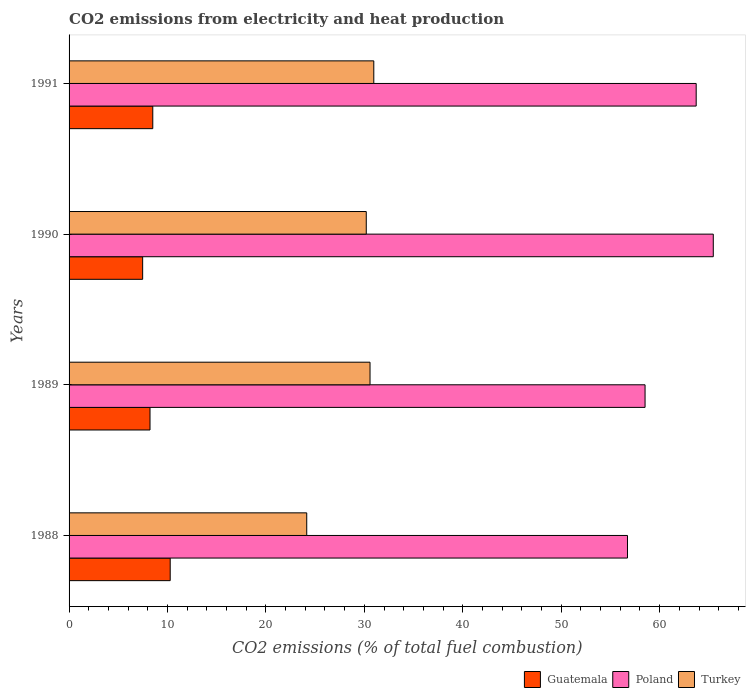How many different coloured bars are there?
Your answer should be very brief. 3. Are the number of bars per tick equal to the number of legend labels?
Keep it short and to the point. Yes. How many bars are there on the 2nd tick from the top?
Your answer should be very brief. 3. In how many cases, is the number of bars for a given year not equal to the number of legend labels?
Offer a terse response. 0. What is the amount of CO2 emitted in Guatemala in 1991?
Make the answer very short. 8.5. Across all years, what is the maximum amount of CO2 emitted in Turkey?
Keep it short and to the point. 30.96. Across all years, what is the minimum amount of CO2 emitted in Poland?
Keep it short and to the point. 56.73. In which year was the amount of CO2 emitted in Guatemala maximum?
Offer a terse response. 1988. What is the total amount of CO2 emitted in Poland in the graph?
Give a very brief answer. 244.42. What is the difference between the amount of CO2 emitted in Poland in 1990 and that in 1991?
Ensure brevity in your answer.  1.74. What is the difference between the amount of CO2 emitted in Poland in 1988 and the amount of CO2 emitted in Guatemala in 1989?
Give a very brief answer. 48.51. What is the average amount of CO2 emitted in Guatemala per year?
Keep it short and to the point. 8.62. In the year 1988, what is the difference between the amount of CO2 emitted in Poland and amount of CO2 emitted in Guatemala?
Your answer should be compact. 46.46. What is the ratio of the amount of CO2 emitted in Guatemala in 1989 to that in 1991?
Make the answer very short. 0.97. Is the amount of CO2 emitted in Guatemala in 1989 less than that in 1990?
Your response must be concise. No. Is the difference between the amount of CO2 emitted in Poland in 1990 and 1991 greater than the difference between the amount of CO2 emitted in Guatemala in 1990 and 1991?
Offer a terse response. Yes. What is the difference between the highest and the second highest amount of CO2 emitted in Poland?
Provide a short and direct response. 1.74. What is the difference between the highest and the lowest amount of CO2 emitted in Poland?
Offer a terse response. 8.72. In how many years, is the amount of CO2 emitted in Turkey greater than the average amount of CO2 emitted in Turkey taken over all years?
Make the answer very short. 3. What does the 3rd bar from the top in 1991 represents?
Offer a very short reply. Guatemala. Is it the case that in every year, the sum of the amount of CO2 emitted in Guatemala and amount of CO2 emitted in Poland is greater than the amount of CO2 emitted in Turkey?
Provide a short and direct response. Yes. Are all the bars in the graph horizontal?
Provide a succinct answer. Yes. Does the graph contain grids?
Your answer should be very brief. No. How many legend labels are there?
Give a very brief answer. 3. How are the legend labels stacked?
Provide a short and direct response. Horizontal. What is the title of the graph?
Give a very brief answer. CO2 emissions from electricity and heat production. Does "Serbia" appear as one of the legend labels in the graph?
Keep it short and to the point. No. What is the label or title of the X-axis?
Your answer should be very brief. CO2 emissions (% of total fuel combustion). What is the CO2 emissions (% of total fuel combustion) of Guatemala in 1988?
Make the answer very short. 10.27. What is the CO2 emissions (% of total fuel combustion) of Poland in 1988?
Keep it short and to the point. 56.73. What is the CO2 emissions (% of total fuel combustion) in Turkey in 1988?
Provide a short and direct response. 24.15. What is the CO2 emissions (% of total fuel combustion) in Guatemala in 1989?
Offer a terse response. 8.22. What is the CO2 emissions (% of total fuel combustion) in Poland in 1989?
Your answer should be very brief. 58.52. What is the CO2 emissions (% of total fuel combustion) in Turkey in 1989?
Your response must be concise. 30.58. What is the CO2 emissions (% of total fuel combustion) in Guatemala in 1990?
Offer a terse response. 7.48. What is the CO2 emissions (% of total fuel combustion) in Poland in 1990?
Ensure brevity in your answer.  65.45. What is the CO2 emissions (% of total fuel combustion) of Turkey in 1990?
Provide a succinct answer. 30.19. What is the CO2 emissions (% of total fuel combustion) in Guatemala in 1991?
Offer a terse response. 8.5. What is the CO2 emissions (% of total fuel combustion) of Poland in 1991?
Ensure brevity in your answer.  63.71. What is the CO2 emissions (% of total fuel combustion) in Turkey in 1991?
Your answer should be very brief. 30.96. Across all years, what is the maximum CO2 emissions (% of total fuel combustion) of Guatemala?
Your response must be concise. 10.27. Across all years, what is the maximum CO2 emissions (% of total fuel combustion) in Poland?
Your response must be concise. 65.45. Across all years, what is the maximum CO2 emissions (% of total fuel combustion) of Turkey?
Keep it short and to the point. 30.96. Across all years, what is the minimum CO2 emissions (% of total fuel combustion) of Guatemala?
Give a very brief answer. 7.48. Across all years, what is the minimum CO2 emissions (% of total fuel combustion) of Poland?
Offer a terse response. 56.73. Across all years, what is the minimum CO2 emissions (% of total fuel combustion) of Turkey?
Your answer should be very brief. 24.15. What is the total CO2 emissions (% of total fuel combustion) of Guatemala in the graph?
Your answer should be compact. 34.48. What is the total CO2 emissions (% of total fuel combustion) of Poland in the graph?
Provide a succinct answer. 244.42. What is the total CO2 emissions (% of total fuel combustion) in Turkey in the graph?
Give a very brief answer. 115.88. What is the difference between the CO2 emissions (% of total fuel combustion) in Guatemala in 1988 and that in 1989?
Your response must be concise. 2.05. What is the difference between the CO2 emissions (% of total fuel combustion) of Poland in 1988 and that in 1989?
Offer a terse response. -1.79. What is the difference between the CO2 emissions (% of total fuel combustion) of Turkey in 1988 and that in 1989?
Keep it short and to the point. -6.43. What is the difference between the CO2 emissions (% of total fuel combustion) of Guatemala in 1988 and that in 1990?
Ensure brevity in your answer.  2.8. What is the difference between the CO2 emissions (% of total fuel combustion) of Poland in 1988 and that in 1990?
Ensure brevity in your answer.  -8.72. What is the difference between the CO2 emissions (% of total fuel combustion) of Turkey in 1988 and that in 1990?
Your answer should be compact. -6.05. What is the difference between the CO2 emissions (% of total fuel combustion) in Guatemala in 1988 and that in 1991?
Offer a very short reply. 1.77. What is the difference between the CO2 emissions (% of total fuel combustion) of Poland in 1988 and that in 1991?
Keep it short and to the point. -6.98. What is the difference between the CO2 emissions (% of total fuel combustion) of Turkey in 1988 and that in 1991?
Provide a succinct answer. -6.81. What is the difference between the CO2 emissions (% of total fuel combustion) in Guatemala in 1989 and that in 1990?
Make the answer very short. 0.75. What is the difference between the CO2 emissions (% of total fuel combustion) in Poland in 1989 and that in 1990?
Your answer should be very brief. -6.93. What is the difference between the CO2 emissions (% of total fuel combustion) in Turkey in 1989 and that in 1990?
Offer a very short reply. 0.38. What is the difference between the CO2 emissions (% of total fuel combustion) of Guatemala in 1989 and that in 1991?
Give a very brief answer. -0.28. What is the difference between the CO2 emissions (% of total fuel combustion) of Poland in 1989 and that in 1991?
Give a very brief answer. -5.19. What is the difference between the CO2 emissions (% of total fuel combustion) of Turkey in 1989 and that in 1991?
Give a very brief answer. -0.38. What is the difference between the CO2 emissions (% of total fuel combustion) in Guatemala in 1990 and that in 1991?
Give a very brief answer. -1.03. What is the difference between the CO2 emissions (% of total fuel combustion) in Poland in 1990 and that in 1991?
Offer a very short reply. 1.74. What is the difference between the CO2 emissions (% of total fuel combustion) of Turkey in 1990 and that in 1991?
Your answer should be very brief. -0.76. What is the difference between the CO2 emissions (% of total fuel combustion) in Guatemala in 1988 and the CO2 emissions (% of total fuel combustion) in Poland in 1989?
Give a very brief answer. -48.25. What is the difference between the CO2 emissions (% of total fuel combustion) in Guatemala in 1988 and the CO2 emissions (% of total fuel combustion) in Turkey in 1989?
Give a very brief answer. -20.3. What is the difference between the CO2 emissions (% of total fuel combustion) of Poland in 1988 and the CO2 emissions (% of total fuel combustion) of Turkey in 1989?
Offer a terse response. 26.16. What is the difference between the CO2 emissions (% of total fuel combustion) of Guatemala in 1988 and the CO2 emissions (% of total fuel combustion) of Poland in 1990?
Keep it short and to the point. -55.18. What is the difference between the CO2 emissions (% of total fuel combustion) in Guatemala in 1988 and the CO2 emissions (% of total fuel combustion) in Turkey in 1990?
Keep it short and to the point. -19.92. What is the difference between the CO2 emissions (% of total fuel combustion) of Poland in 1988 and the CO2 emissions (% of total fuel combustion) of Turkey in 1990?
Offer a very short reply. 26.54. What is the difference between the CO2 emissions (% of total fuel combustion) of Guatemala in 1988 and the CO2 emissions (% of total fuel combustion) of Poland in 1991?
Give a very brief answer. -53.44. What is the difference between the CO2 emissions (% of total fuel combustion) in Guatemala in 1988 and the CO2 emissions (% of total fuel combustion) in Turkey in 1991?
Give a very brief answer. -20.69. What is the difference between the CO2 emissions (% of total fuel combustion) of Poland in 1988 and the CO2 emissions (% of total fuel combustion) of Turkey in 1991?
Your response must be concise. 25.77. What is the difference between the CO2 emissions (% of total fuel combustion) in Guatemala in 1989 and the CO2 emissions (% of total fuel combustion) in Poland in 1990?
Keep it short and to the point. -57.23. What is the difference between the CO2 emissions (% of total fuel combustion) of Guatemala in 1989 and the CO2 emissions (% of total fuel combustion) of Turkey in 1990?
Provide a short and direct response. -21.97. What is the difference between the CO2 emissions (% of total fuel combustion) of Poland in 1989 and the CO2 emissions (% of total fuel combustion) of Turkey in 1990?
Provide a succinct answer. 28.32. What is the difference between the CO2 emissions (% of total fuel combustion) of Guatemala in 1989 and the CO2 emissions (% of total fuel combustion) of Poland in 1991?
Keep it short and to the point. -55.49. What is the difference between the CO2 emissions (% of total fuel combustion) of Guatemala in 1989 and the CO2 emissions (% of total fuel combustion) of Turkey in 1991?
Provide a short and direct response. -22.74. What is the difference between the CO2 emissions (% of total fuel combustion) of Poland in 1989 and the CO2 emissions (% of total fuel combustion) of Turkey in 1991?
Offer a very short reply. 27.56. What is the difference between the CO2 emissions (% of total fuel combustion) in Guatemala in 1990 and the CO2 emissions (% of total fuel combustion) in Poland in 1991?
Your answer should be compact. -56.24. What is the difference between the CO2 emissions (% of total fuel combustion) of Guatemala in 1990 and the CO2 emissions (% of total fuel combustion) of Turkey in 1991?
Your response must be concise. -23.48. What is the difference between the CO2 emissions (% of total fuel combustion) in Poland in 1990 and the CO2 emissions (% of total fuel combustion) in Turkey in 1991?
Provide a short and direct response. 34.49. What is the average CO2 emissions (% of total fuel combustion) of Guatemala per year?
Offer a terse response. 8.62. What is the average CO2 emissions (% of total fuel combustion) in Poland per year?
Offer a very short reply. 61.1. What is the average CO2 emissions (% of total fuel combustion) of Turkey per year?
Your answer should be compact. 28.97. In the year 1988, what is the difference between the CO2 emissions (% of total fuel combustion) of Guatemala and CO2 emissions (% of total fuel combustion) of Poland?
Keep it short and to the point. -46.46. In the year 1988, what is the difference between the CO2 emissions (% of total fuel combustion) in Guatemala and CO2 emissions (% of total fuel combustion) in Turkey?
Offer a very short reply. -13.87. In the year 1988, what is the difference between the CO2 emissions (% of total fuel combustion) of Poland and CO2 emissions (% of total fuel combustion) of Turkey?
Give a very brief answer. 32.59. In the year 1989, what is the difference between the CO2 emissions (% of total fuel combustion) of Guatemala and CO2 emissions (% of total fuel combustion) of Poland?
Offer a terse response. -50.3. In the year 1989, what is the difference between the CO2 emissions (% of total fuel combustion) in Guatemala and CO2 emissions (% of total fuel combustion) in Turkey?
Ensure brevity in your answer.  -22.35. In the year 1989, what is the difference between the CO2 emissions (% of total fuel combustion) of Poland and CO2 emissions (% of total fuel combustion) of Turkey?
Provide a short and direct response. 27.94. In the year 1990, what is the difference between the CO2 emissions (% of total fuel combustion) in Guatemala and CO2 emissions (% of total fuel combustion) in Poland?
Provide a short and direct response. -57.97. In the year 1990, what is the difference between the CO2 emissions (% of total fuel combustion) of Guatemala and CO2 emissions (% of total fuel combustion) of Turkey?
Your answer should be compact. -22.72. In the year 1990, what is the difference between the CO2 emissions (% of total fuel combustion) of Poland and CO2 emissions (% of total fuel combustion) of Turkey?
Provide a succinct answer. 35.26. In the year 1991, what is the difference between the CO2 emissions (% of total fuel combustion) of Guatemala and CO2 emissions (% of total fuel combustion) of Poland?
Provide a succinct answer. -55.21. In the year 1991, what is the difference between the CO2 emissions (% of total fuel combustion) in Guatemala and CO2 emissions (% of total fuel combustion) in Turkey?
Offer a very short reply. -22.46. In the year 1991, what is the difference between the CO2 emissions (% of total fuel combustion) of Poland and CO2 emissions (% of total fuel combustion) of Turkey?
Your response must be concise. 32.75. What is the ratio of the CO2 emissions (% of total fuel combustion) in Guatemala in 1988 to that in 1989?
Provide a succinct answer. 1.25. What is the ratio of the CO2 emissions (% of total fuel combustion) of Poland in 1988 to that in 1989?
Ensure brevity in your answer.  0.97. What is the ratio of the CO2 emissions (% of total fuel combustion) in Turkey in 1988 to that in 1989?
Your answer should be compact. 0.79. What is the ratio of the CO2 emissions (% of total fuel combustion) in Guatemala in 1988 to that in 1990?
Your response must be concise. 1.37. What is the ratio of the CO2 emissions (% of total fuel combustion) in Poland in 1988 to that in 1990?
Keep it short and to the point. 0.87. What is the ratio of the CO2 emissions (% of total fuel combustion) in Turkey in 1988 to that in 1990?
Provide a short and direct response. 0.8. What is the ratio of the CO2 emissions (% of total fuel combustion) of Guatemala in 1988 to that in 1991?
Your answer should be very brief. 1.21. What is the ratio of the CO2 emissions (% of total fuel combustion) of Poland in 1988 to that in 1991?
Your answer should be very brief. 0.89. What is the ratio of the CO2 emissions (% of total fuel combustion) in Turkey in 1988 to that in 1991?
Keep it short and to the point. 0.78. What is the ratio of the CO2 emissions (% of total fuel combustion) of Guatemala in 1989 to that in 1990?
Your answer should be compact. 1.1. What is the ratio of the CO2 emissions (% of total fuel combustion) of Poland in 1989 to that in 1990?
Ensure brevity in your answer.  0.89. What is the ratio of the CO2 emissions (% of total fuel combustion) of Turkey in 1989 to that in 1990?
Make the answer very short. 1.01. What is the ratio of the CO2 emissions (% of total fuel combustion) in Guatemala in 1989 to that in 1991?
Offer a terse response. 0.97. What is the ratio of the CO2 emissions (% of total fuel combustion) in Poland in 1989 to that in 1991?
Provide a succinct answer. 0.92. What is the ratio of the CO2 emissions (% of total fuel combustion) in Turkey in 1989 to that in 1991?
Your answer should be compact. 0.99. What is the ratio of the CO2 emissions (% of total fuel combustion) in Guatemala in 1990 to that in 1991?
Offer a very short reply. 0.88. What is the ratio of the CO2 emissions (% of total fuel combustion) in Poland in 1990 to that in 1991?
Offer a very short reply. 1.03. What is the ratio of the CO2 emissions (% of total fuel combustion) in Turkey in 1990 to that in 1991?
Ensure brevity in your answer.  0.98. What is the difference between the highest and the second highest CO2 emissions (% of total fuel combustion) of Guatemala?
Your answer should be compact. 1.77. What is the difference between the highest and the second highest CO2 emissions (% of total fuel combustion) in Poland?
Make the answer very short. 1.74. What is the difference between the highest and the second highest CO2 emissions (% of total fuel combustion) of Turkey?
Ensure brevity in your answer.  0.38. What is the difference between the highest and the lowest CO2 emissions (% of total fuel combustion) in Guatemala?
Offer a terse response. 2.8. What is the difference between the highest and the lowest CO2 emissions (% of total fuel combustion) in Poland?
Provide a short and direct response. 8.72. What is the difference between the highest and the lowest CO2 emissions (% of total fuel combustion) in Turkey?
Your response must be concise. 6.81. 